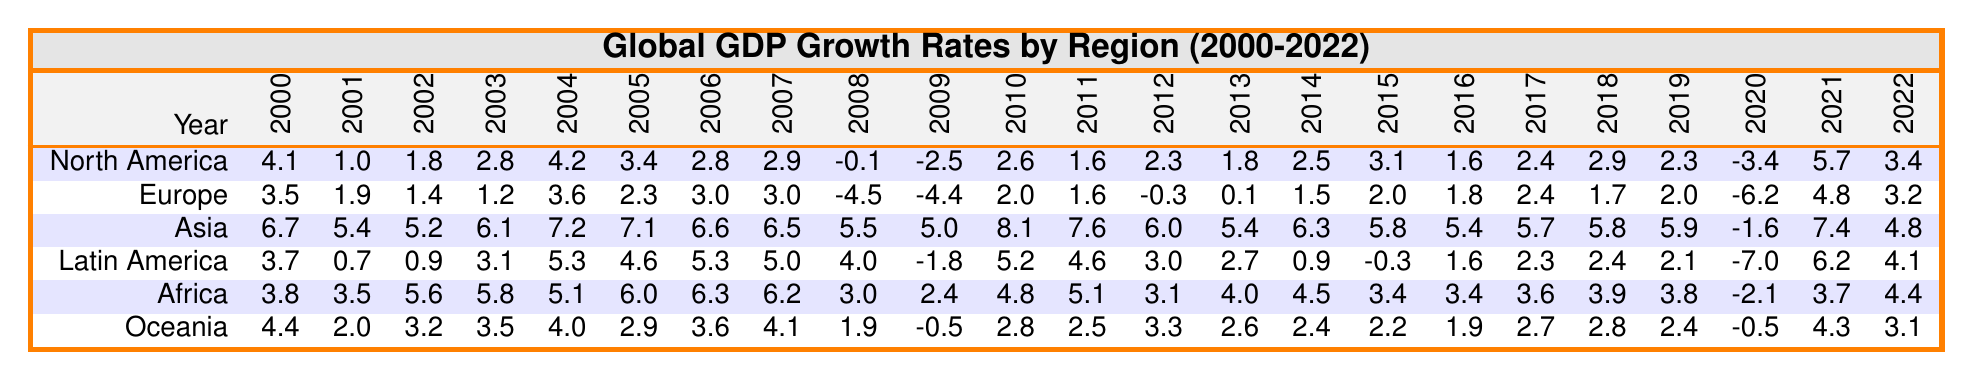What was the highest GDP growth rate recorded in Asia during the years 2000-2022? Looking at the Asia row, the values show a peak of 8.1 in the year 2010.
Answer: 8.1 What was the GDP growth rate in Europe in 2009? Referring to the Europe row for the year 2009, the value is -4.4.
Answer: -4.4 Which region had the highest average GDP growth rate from 2000 to 2022? To find this, we calculate the average for each region: North America = 2.47, Europe = 1.25, Asia = 5.39, Latin America = 2.41, Africa = 3.62, and Oceania = 2.73. The highest average is for Asia.
Answer: Asia What was the GDP growth rate for Latin America in the year 2015? Checking the Latin America row for 2015, the value is -0.3.
Answer: -0.3 Which region experienced the most significant decline in GDP growth from 2019 to 2020? Evaluating the growth rates for each region: North America: -3.4 (2019) to 5.7 (2020), Europe: -6.2 to 4.8, Asia: 5.9 to -1.6, Latin America: 2.1 to -7.0, Africa: 3.8 to -2.1, Oceania: 2.4 to -0.5. Latin America had the largest drop of 9.1.
Answer: Latin America Did Oceania have a positive GDP growth rate for every year from 2000 to 2022? Inspecting the Oceania row, the values show negative growth in 2009 and 2020, indicating that it did not have positive growth in every year.
Answer: No What was the GDP growth rate for Africa in 2012 and how does it compare to the growth rate in 2013? The rate for Africa in 2012 is 3.1 and in 2013 is 4.0, showing an increase of 0.9 between the two years.
Answer: 3.1 and it increased to 4.0 What is the average GDP growth rate for North America over the years 2000 to 2022? First, we sum the values in the North America row (4.1 + 1.0 + 1.8 + 2.8 + 4.2 + 3.4 + 2.8 + 2.9 - 0.1 - 2.5 + 2.6 + 1.6 + 2.3 + 1.8 + 2.5 + 3.1 + 1.6 + 2.4 + 2.9 + 2.3 - 3.4 + 5.7 + 3.4 =  51.4) and divide by 23 (the number of years) to get an average of 2.24.
Answer: 2.24 What was the trend of GDP growth rates in Asia from 2000 to 2022? By analyzing the Asia row, we see a general pattern of growth until 2010, followed by a decline in 2020, and a recovery in 2021 and 2022. Overall, Asia had consistent growth with only one year of negative growth.
Answer: General upward trend with a dip in 2020 